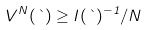<formula> <loc_0><loc_0><loc_500><loc_500>V ^ { N } ( \theta ) \geq I ( \theta ) ^ { - 1 } / N</formula> 